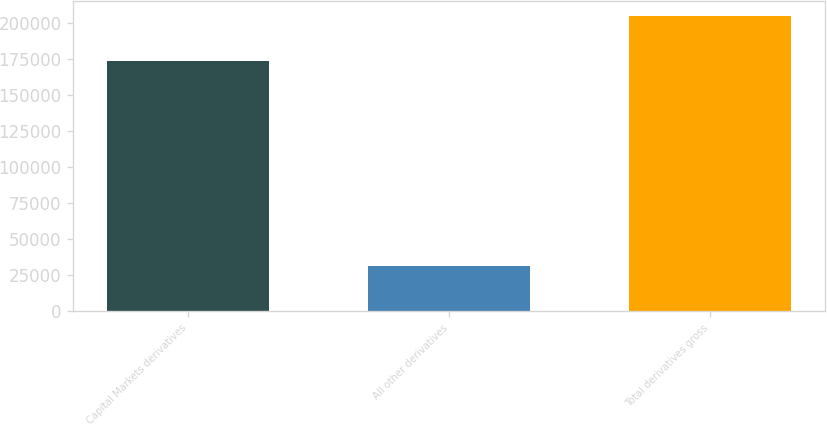Convert chart to OTSL. <chart><loc_0><loc_0><loc_500><loc_500><bar_chart><fcel>Capital Markets derivatives<fcel>All other derivatives<fcel>Total derivatives gross<nl><fcel>173226<fcel>31627<fcel>204853<nl></chart> 